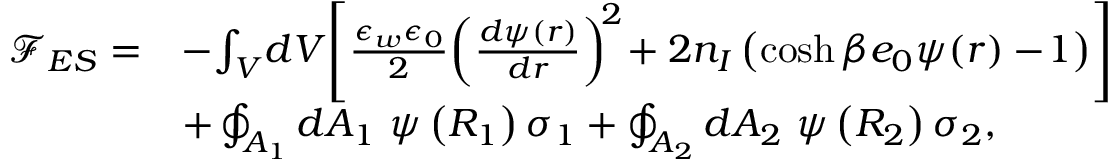Convert formula to latex. <formula><loc_0><loc_0><loc_500><loc_500>\begin{array} { r l } { { \mathcal { F } } _ { E S } = } & { - \, \int _ { V } \, d V \, \left [ \frac { \epsilon _ { w } \epsilon _ { 0 } } { 2 } \, \left ( \frac { d \psi ( r ) } { d r } \right ) ^ { \, 2 } \, + 2 n _ { I } \left ( \cosh { \beta e _ { 0 } \psi ( r ) } - \, 1 \right ) \right ] } \\ & { + \oint _ { A _ { 1 } } d A _ { 1 } \psi \left ( R _ { 1 } \right ) \sigma _ { 1 } + \oint _ { A _ { 2 } } d A _ { 2 } \psi \left ( R _ { 2 } \right ) \sigma _ { 2 } , } \end{array}</formula> 